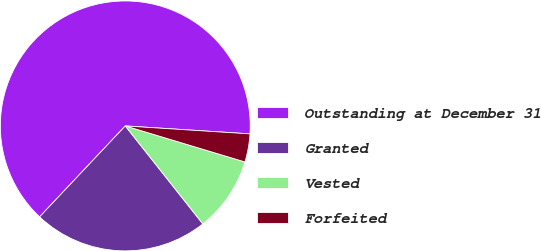Convert chart. <chart><loc_0><loc_0><loc_500><loc_500><pie_chart><fcel>Outstanding at December 31<fcel>Granted<fcel>Vested<fcel>Forfeited<nl><fcel>63.99%<fcel>22.68%<fcel>9.69%<fcel>3.64%<nl></chart> 